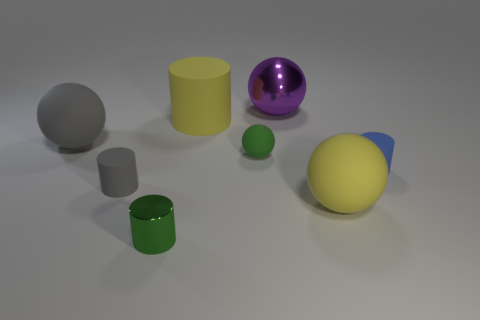Can you describe the shapes and colors of the objects in the image? Certainly! The image shows a collection of geometric shapes. There's a large yellow cylinder, a small green cylinder, and a small gray cylinder. Additionally, we see a large blue and yellow capsule-shape, a purple sphere, and a large gray sphere that seems to be made of a matte material, contrasting with the shiny surfaces of the other objects. 